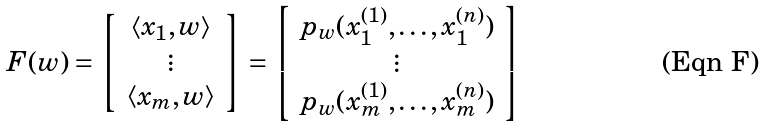Convert formula to latex. <formula><loc_0><loc_0><loc_500><loc_500>F ( w ) = \left [ \begin{array} { c } \left < x _ { 1 } , w \right > \\ \vdots \\ \left < x _ { m } , w \right > \end{array} \right ] = \left [ \begin{array} { c } p _ { w } ( x _ { 1 } ^ { ( 1 ) } , \dots , x _ { 1 } ^ { ( n ) } ) \\ \vdots \\ p _ { w } ( x _ { m } ^ { ( 1 ) } , \dots , x _ { m } ^ { ( n ) } ) \end{array} \right ]</formula> 